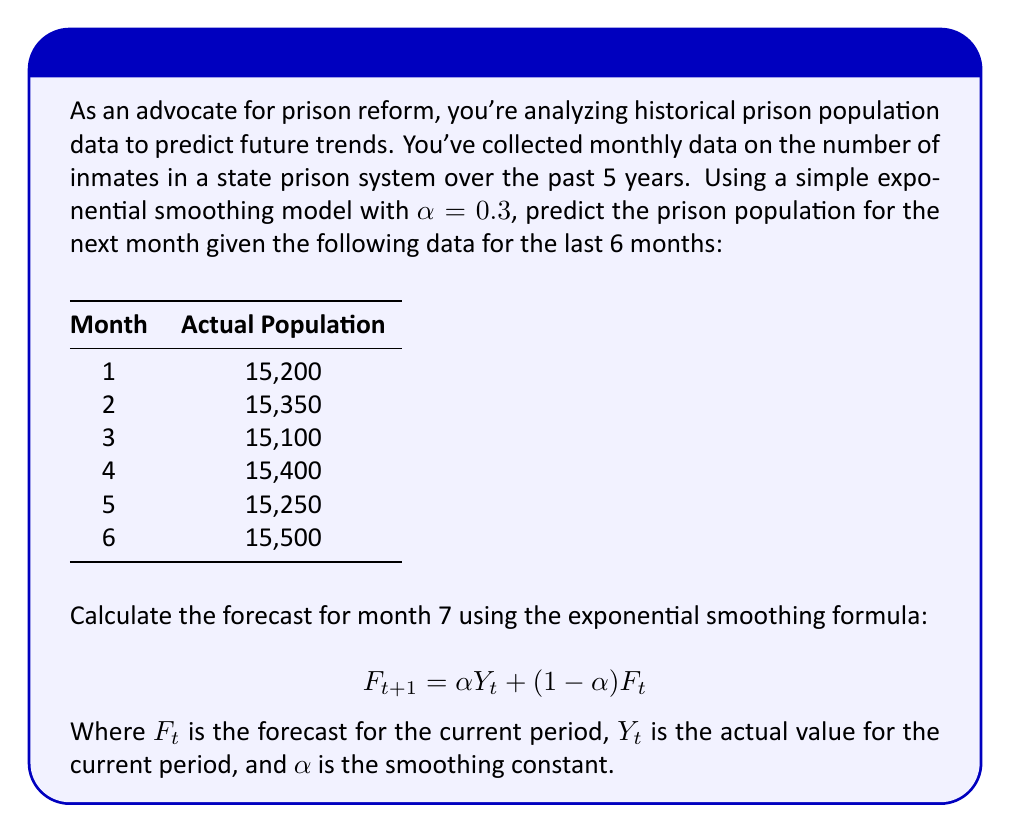Provide a solution to this math problem. Let's approach this step-by-step:

1) First, we need to calculate the initial forecast $F_1$. We'll use the average of the first few months as our initial forecast:

   $F_1 = (15200 + 15350 + 15100) / 3 = 15216.67$

2) Now we can calculate the forecast for each subsequent month using the formula:

   $F_{t+1} = 0.3Y_t + 0.7F_t$

3) For month 2:
   $F_2 = 0.3(15200) + 0.7(15216.67) = 4560 + 10651.67 = 15211.67$

4) For month 3:
   $F_3 = 0.3(15350) + 0.7(15211.67) = 4605 + 10648.17 = 15253.17$

5) For month 4:
   $F_4 = 0.3(15100) + 0.7(15253.17) = 4530 + 10677.22 = 15207.22$

6) For month 5:
   $F_5 = 0.3(15400) + 0.7(15207.22) = 4620 + 10645.05 = 15265.05$

7) For month 6:
   $F_6 = 0.3(15250) + 0.7(15265.05) = 4575 + 10685.54 = 15260.54$

8) Finally, for month 7 (our prediction):
   $F_7 = 0.3(15500) + 0.7(15260.54) = 4650 + 10682.38 = 15332.38$

Therefore, the forecast for month 7 is approximately 15,332 inmates.
Answer: 15,332 inmates 